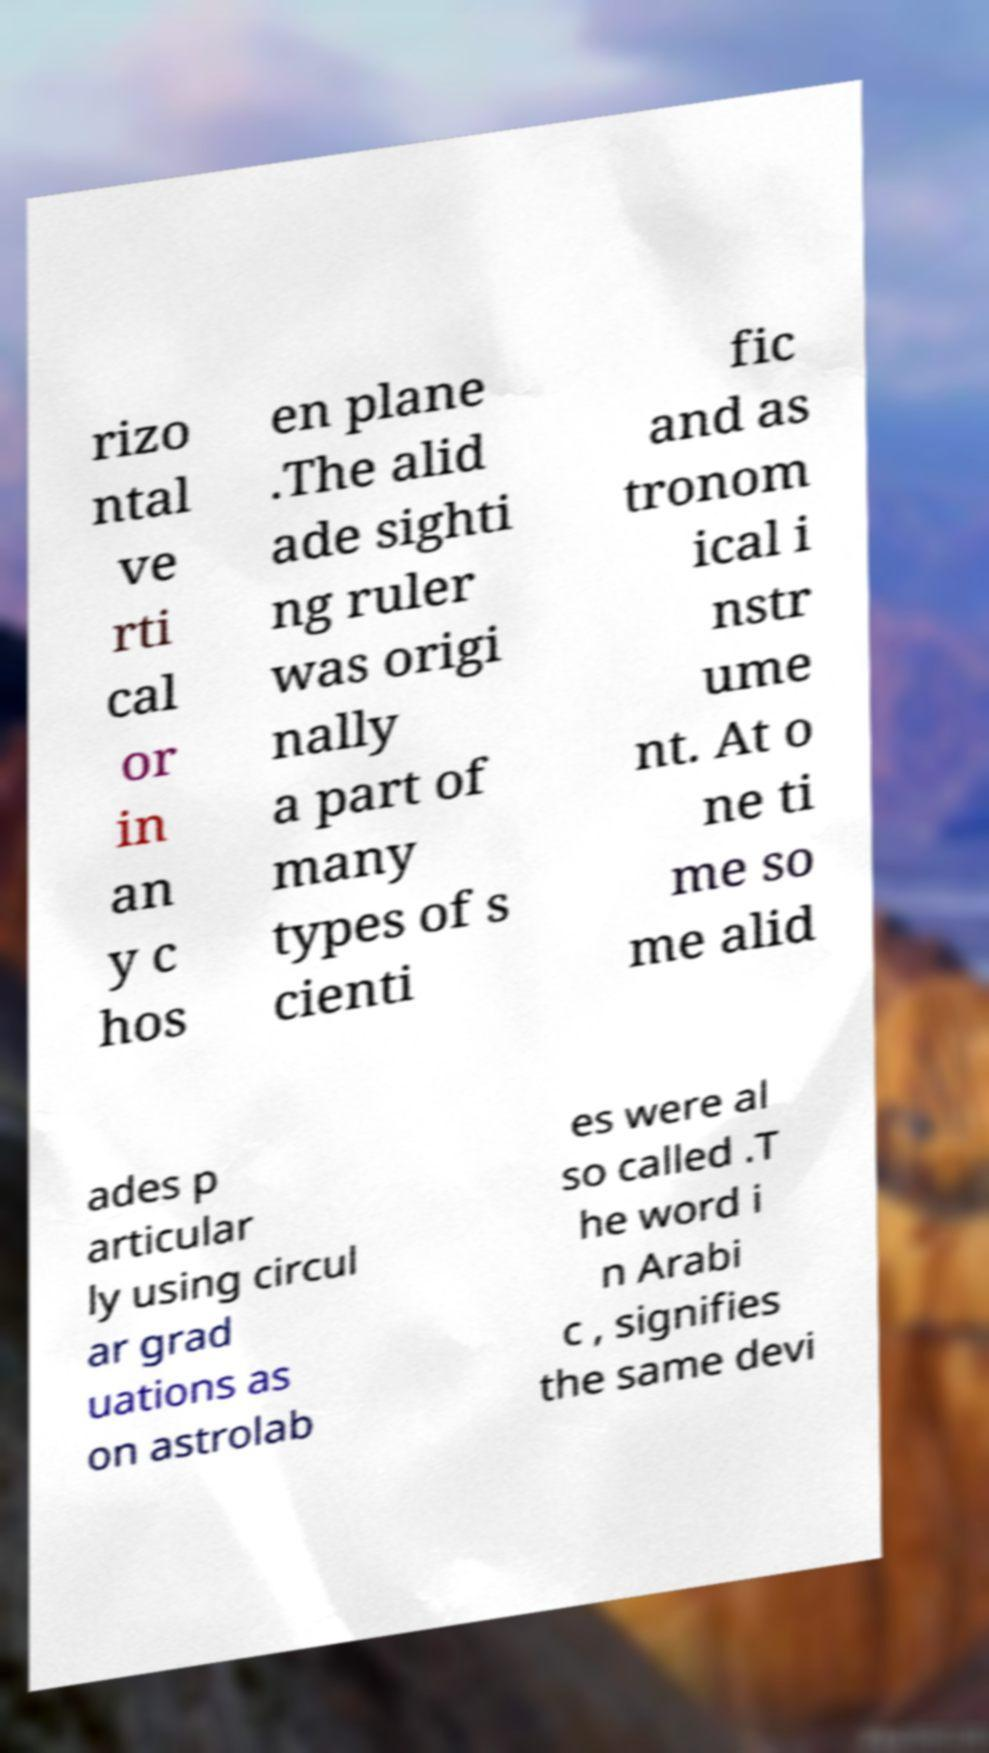Could you extract and type out the text from this image? rizo ntal ve rti cal or in an y c hos en plane .The alid ade sighti ng ruler was origi nally a part of many types of s cienti fic and as tronom ical i nstr ume nt. At o ne ti me so me alid ades p articular ly using circul ar grad uations as on astrolab es were al so called .T he word i n Arabi c , signifies the same devi 